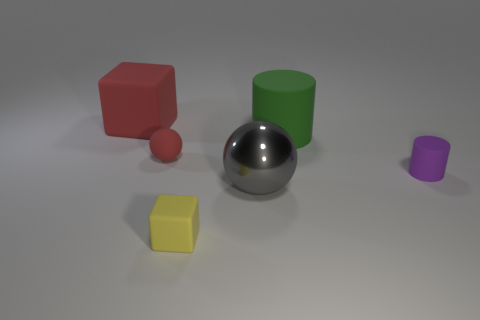What material is the big gray object that is the same shape as the tiny red matte thing?
Offer a terse response. Metal. What number of tiny spheres have the same color as the large cube?
Offer a terse response. 1. How big is the yellow matte thing?
Provide a short and direct response. Small. There is a large green matte thing; does it have the same shape as the small thing that is right of the large green thing?
Keep it short and to the point. Yes. What is the color of the large thing that is the same material as the red cube?
Give a very brief answer. Green. There is a matte cube in front of the small purple rubber object; how big is it?
Offer a very short reply. Small. Is the number of cubes that are behind the large gray ball less than the number of blue rubber cubes?
Provide a succinct answer. No. Is the color of the tiny rubber sphere the same as the big block?
Make the answer very short. Yes. Is the number of purple matte cylinders less than the number of spheres?
Provide a succinct answer. Yes. What is the color of the matte block behind the ball to the right of the small yellow block?
Give a very brief answer. Red. 